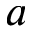<formula> <loc_0><loc_0><loc_500><loc_500>a</formula> 